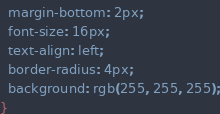<code> <loc_0><loc_0><loc_500><loc_500><_CSS_>  margin-bottom: 2px;
  font-size: 16px;
  text-align: left;
  border-radius: 4px;
  background: rgb(255, 255, 255);
}
</code> 